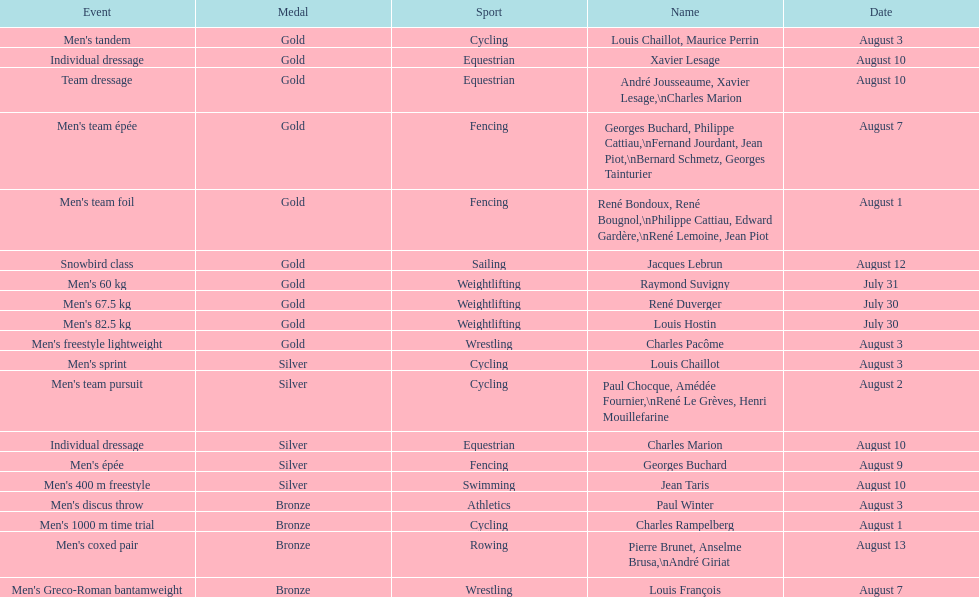Which event won the most medals? Cycling. I'm looking to parse the entire table for insights. Could you assist me with that? {'header': ['Event', 'Medal', 'Sport', 'Name', 'Date'], 'rows': [["Men's tandem", 'Gold', 'Cycling', 'Louis Chaillot, Maurice Perrin', 'August 3'], ['Individual dressage', 'Gold', 'Equestrian', 'Xavier Lesage', 'August 10'], ['Team dressage', 'Gold', 'Equestrian', 'André Jousseaume, Xavier Lesage,\\nCharles Marion', 'August 10'], ["Men's team épée", 'Gold', 'Fencing', 'Georges Buchard, Philippe Cattiau,\\nFernand Jourdant, Jean Piot,\\nBernard Schmetz, Georges Tainturier', 'August 7'], ["Men's team foil", 'Gold', 'Fencing', 'René Bondoux, René Bougnol,\\nPhilippe Cattiau, Edward Gardère,\\nRené Lemoine, Jean Piot', 'August 1'], ['Snowbird class', 'Gold', 'Sailing', 'Jacques Lebrun', 'August 12'], ["Men's 60 kg", 'Gold', 'Weightlifting', 'Raymond Suvigny', 'July 31'], ["Men's 67.5 kg", 'Gold', 'Weightlifting', 'René Duverger', 'July 30'], ["Men's 82.5 kg", 'Gold', 'Weightlifting', 'Louis Hostin', 'July 30'], ["Men's freestyle lightweight", 'Gold', 'Wrestling', 'Charles Pacôme', 'August 3'], ["Men's sprint", 'Silver', 'Cycling', 'Louis Chaillot', 'August 3'], ["Men's team pursuit", 'Silver', 'Cycling', 'Paul Chocque, Amédée Fournier,\\nRené Le Grèves, Henri Mouillefarine', 'August 2'], ['Individual dressage', 'Silver', 'Equestrian', 'Charles Marion', 'August 10'], ["Men's épée", 'Silver', 'Fencing', 'Georges Buchard', 'August 9'], ["Men's 400 m freestyle", 'Silver', 'Swimming', 'Jean Taris', 'August 10'], ["Men's discus throw", 'Bronze', 'Athletics', 'Paul Winter', 'August 3'], ["Men's 1000 m time trial", 'Bronze', 'Cycling', 'Charles Rampelberg', 'August 1'], ["Men's coxed pair", 'Bronze', 'Rowing', 'Pierre Brunet, Anselme Brusa,\\nAndré Giriat', 'August 13'], ["Men's Greco-Roman bantamweight", 'Bronze', 'Wrestling', 'Louis François', 'August 7']]} 